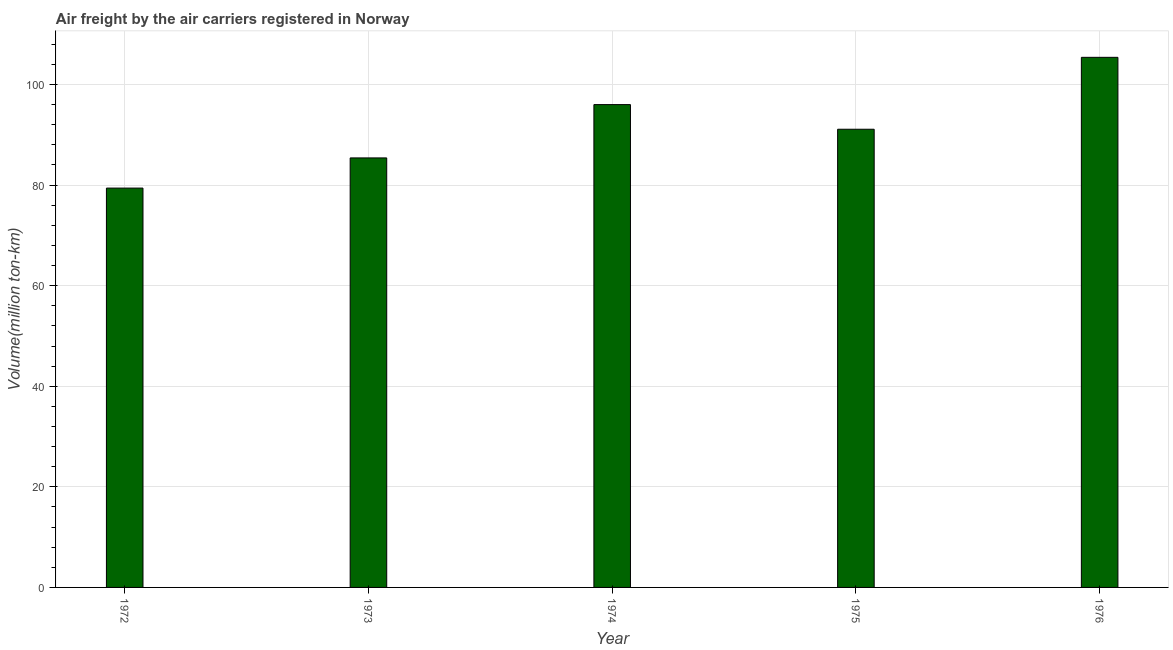Does the graph contain any zero values?
Provide a succinct answer. No. Does the graph contain grids?
Make the answer very short. Yes. What is the title of the graph?
Your response must be concise. Air freight by the air carriers registered in Norway. What is the label or title of the Y-axis?
Your answer should be very brief. Volume(million ton-km). What is the air freight in 1972?
Provide a succinct answer. 79.4. Across all years, what is the maximum air freight?
Offer a terse response. 105.4. Across all years, what is the minimum air freight?
Make the answer very short. 79.4. In which year was the air freight maximum?
Ensure brevity in your answer.  1976. What is the sum of the air freight?
Make the answer very short. 457.3. What is the average air freight per year?
Keep it short and to the point. 91.46. What is the median air freight?
Give a very brief answer. 91.1. What is the ratio of the air freight in 1975 to that in 1976?
Ensure brevity in your answer.  0.86. Is the difference between the air freight in 1972 and 1975 greater than the difference between any two years?
Give a very brief answer. No. What is the difference between the highest and the second highest air freight?
Keep it short and to the point. 9.4. Is the sum of the air freight in 1974 and 1976 greater than the maximum air freight across all years?
Offer a very short reply. Yes. What is the difference between the highest and the lowest air freight?
Provide a short and direct response. 26. How many bars are there?
Your answer should be very brief. 5. Are all the bars in the graph horizontal?
Make the answer very short. No. How many years are there in the graph?
Provide a succinct answer. 5. What is the Volume(million ton-km) in 1972?
Make the answer very short. 79.4. What is the Volume(million ton-km) in 1973?
Provide a succinct answer. 85.4. What is the Volume(million ton-km) in 1974?
Offer a very short reply. 96. What is the Volume(million ton-km) of 1975?
Give a very brief answer. 91.1. What is the Volume(million ton-km) of 1976?
Your answer should be very brief. 105.4. What is the difference between the Volume(million ton-km) in 1972 and 1973?
Offer a terse response. -6. What is the difference between the Volume(million ton-km) in 1972 and 1974?
Ensure brevity in your answer.  -16.6. What is the difference between the Volume(million ton-km) in 1973 and 1974?
Offer a terse response. -10.6. What is the difference between the Volume(million ton-km) in 1974 and 1975?
Provide a short and direct response. 4.9. What is the difference between the Volume(million ton-km) in 1975 and 1976?
Offer a terse response. -14.3. What is the ratio of the Volume(million ton-km) in 1972 to that in 1973?
Keep it short and to the point. 0.93. What is the ratio of the Volume(million ton-km) in 1972 to that in 1974?
Provide a short and direct response. 0.83. What is the ratio of the Volume(million ton-km) in 1972 to that in 1975?
Give a very brief answer. 0.87. What is the ratio of the Volume(million ton-km) in 1972 to that in 1976?
Your response must be concise. 0.75. What is the ratio of the Volume(million ton-km) in 1973 to that in 1974?
Keep it short and to the point. 0.89. What is the ratio of the Volume(million ton-km) in 1973 to that in 1975?
Keep it short and to the point. 0.94. What is the ratio of the Volume(million ton-km) in 1973 to that in 1976?
Your answer should be very brief. 0.81. What is the ratio of the Volume(million ton-km) in 1974 to that in 1975?
Ensure brevity in your answer.  1.05. What is the ratio of the Volume(million ton-km) in 1974 to that in 1976?
Offer a very short reply. 0.91. What is the ratio of the Volume(million ton-km) in 1975 to that in 1976?
Give a very brief answer. 0.86. 